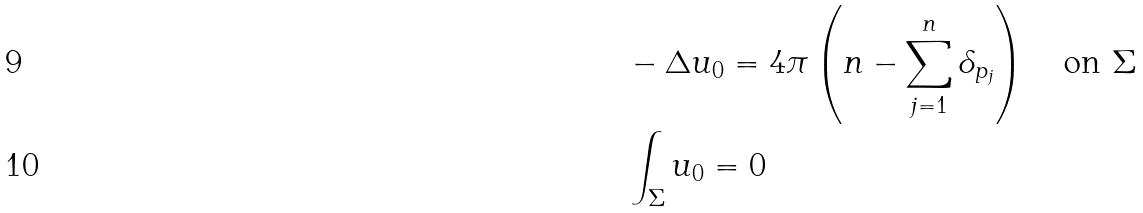<formula> <loc_0><loc_0><loc_500><loc_500>& - \Delta u _ { 0 } = 4 \pi \left ( n - \sum _ { j = 1 } ^ { n } \delta _ { p _ { j } } \right ) \quad \text {on} \ \Sigma \\ & \int _ { \Sigma } u _ { 0 } = 0</formula> 